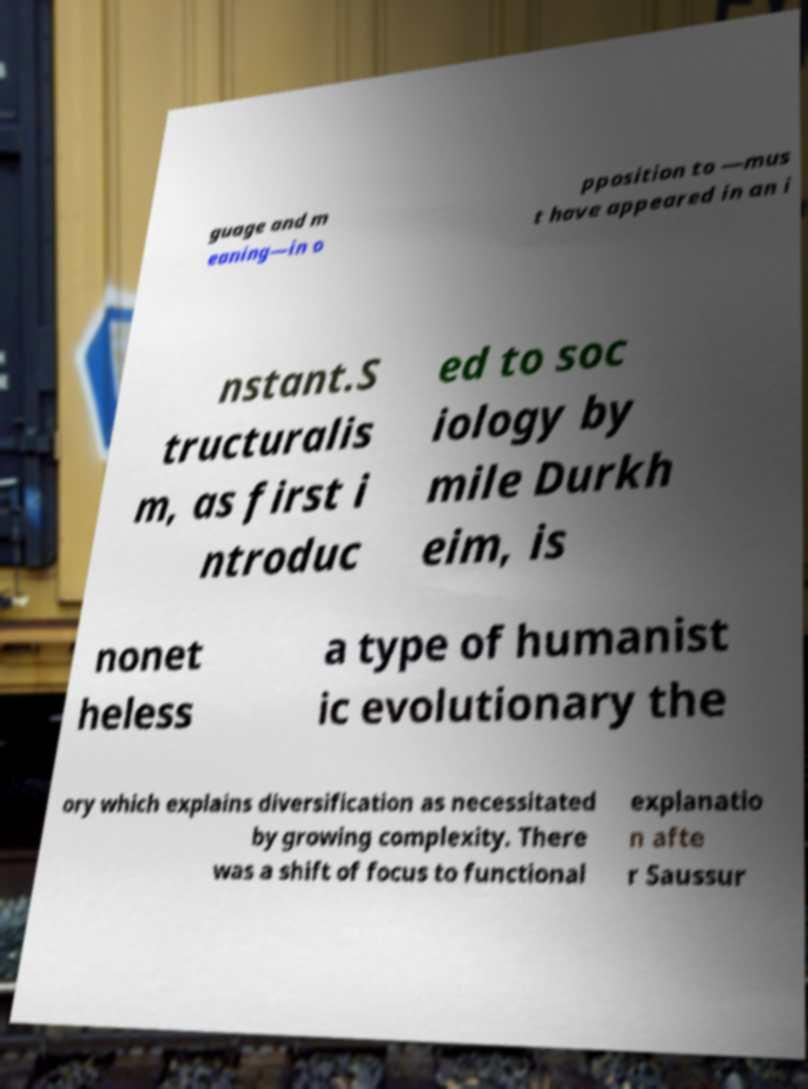Please read and relay the text visible in this image. What does it say? guage and m eaning—in o pposition to —mus t have appeared in an i nstant.S tructuralis m, as first i ntroduc ed to soc iology by mile Durkh eim, is nonet heless a type of humanist ic evolutionary the ory which explains diversification as necessitated by growing complexity. There was a shift of focus to functional explanatio n afte r Saussur 